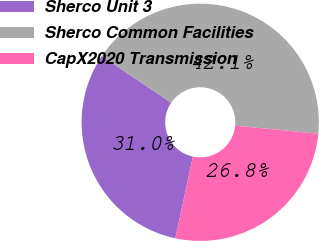Convert chart to OTSL. <chart><loc_0><loc_0><loc_500><loc_500><pie_chart><fcel>Sherco Unit 3<fcel>Sherco Common Facilities<fcel>CapX2020 Transmission<nl><fcel>31.05%<fcel>42.11%<fcel>26.84%<nl></chart> 